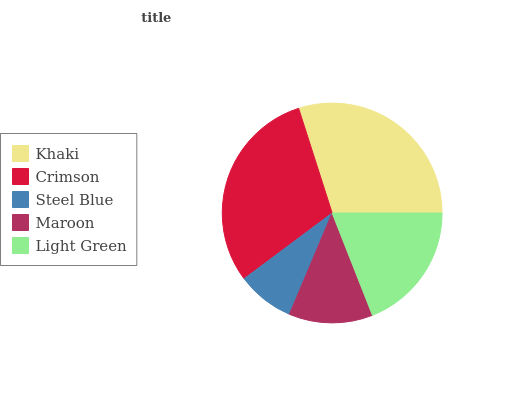Is Steel Blue the minimum?
Answer yes or no. Yes. Is Crimson the maximum?
Answer yes or no. Yes. Is Crimson the minimum?
Answer yes or no. No. Is Steel Blue the maximum?
Answer yes or no. No. Is Crimson greater than Steel Blue?
Answer yes or no. Yes. Is Steel Blue less than Crimson?
Answer yes or no. Yes. Is Steel Blue greater than Crimson?
Answer yes or no. No. Is Crimson less than Steel Blue?
Answer yes or no. No. Is Light Green the high median?
Answer yes or no. Yes. Is Light Green the low median?
Answer yes or no. Yes. Is Khaki the high median?
Answer yes or no. No. Is Steel Blue the low median?
Answer yes or no. No. 